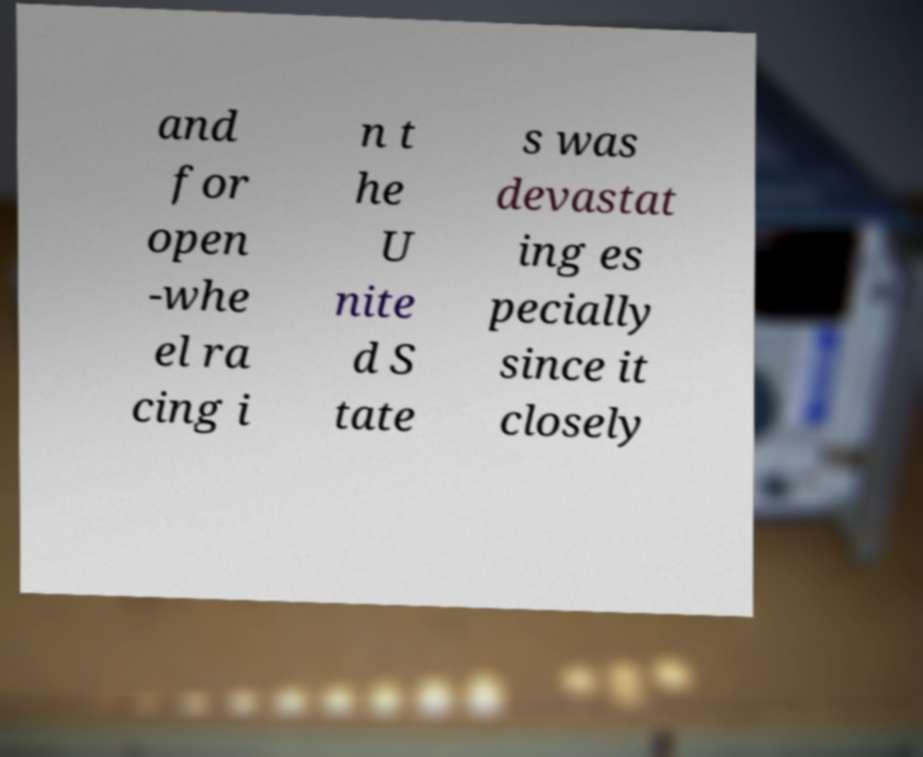Please identify and transcribe the text found in this image. and for open -whe el ra cing i n t he U nite d S tate s was devastat ing es pecially since it closely 